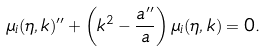Convert formula to latex. <formula><loc_0><loc_0><loc_500><loc_500>\mu _ { i } ( \eta , { k } ) ^ { \prime \prime } + \left ( k ^ { 2 } - \frac { a ^ { \prime \prime } } { a } \right ) \mu _ { i } ( \eta , { k } ) = 0 .</formula> 